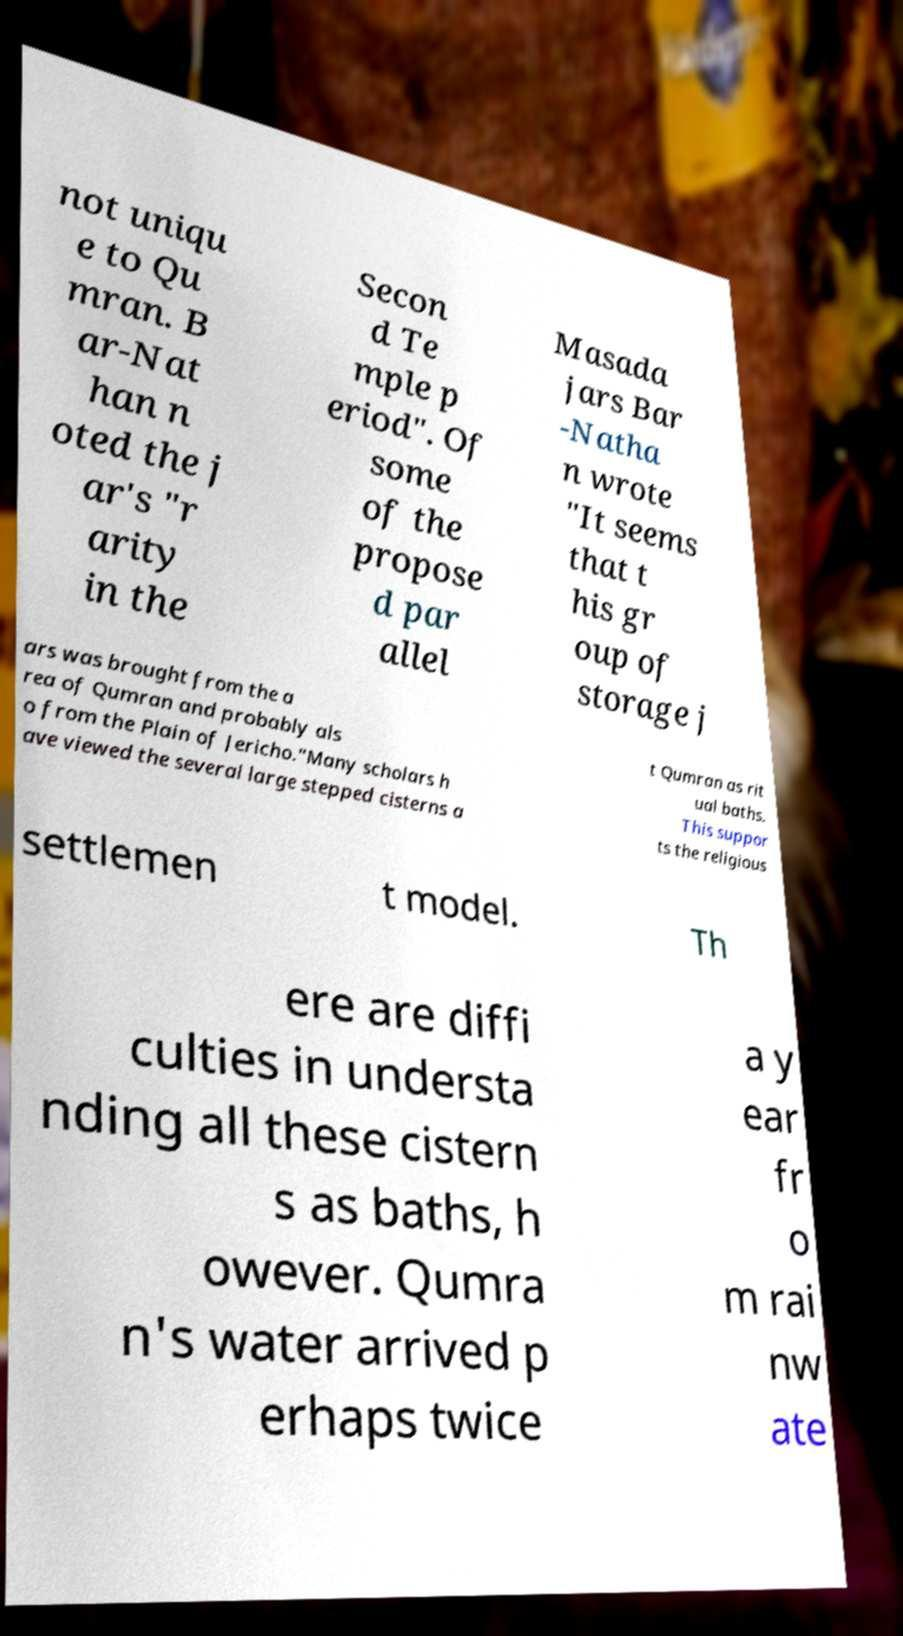What messages or text are displayed in this image? I need them in a readable, typed format. not uniqu e to Qu mran. B ar-Nat han n oted the j ar's "r arity in the Secon d Te mple p eriod". Of some of the propose d par allel Masada jars Bar -Natha n wrote "It seems that t his gr oup of storage j ars was brought from the a rea of Qumran and probably als o from the Plain of Jericho."Many scholars h ave viewed the several large stepped cisterns a t Qumran as rit ual baths. This suppor ts the religious settlemen t model. Th ere are diffi culties in understa nding all these cistern s as baths, h owever. Qumra n's water arrived p erhaps twice a y ear fr o m rai nw ate 